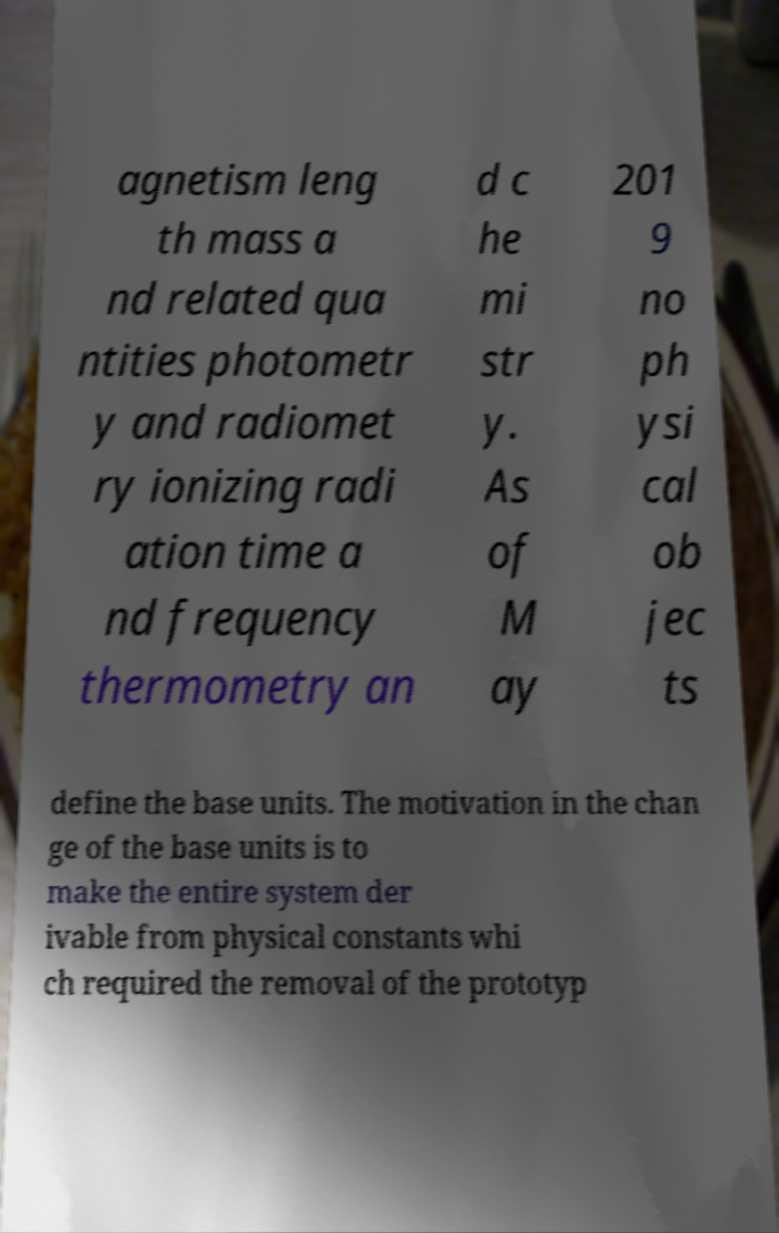Please read and relay the text visible in this image. What does it say? agnetism leng th mass a nd related qua ntities photometr y and radiomet ry ionizing radi ation time a nd frequency thermometry an d c he mi str y. As of M ay 201 9 no ph ysi cal ob jec ts define the base units. The motivation in the chan ge of the base units is to make the entire system der ivable from physical constants whi ch required the removal of the prototyp 